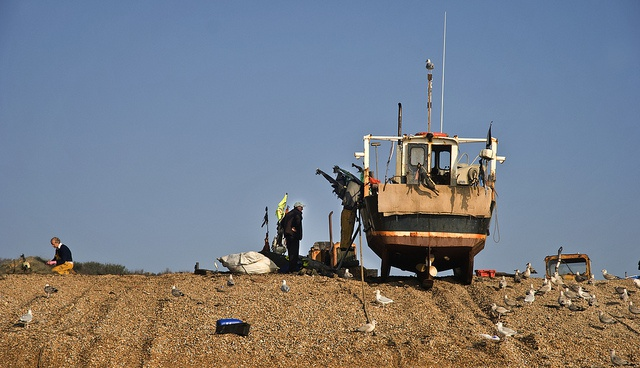Describe the objects in this image and their specific colors. I can see boat in gray, black, tan, and maroon tones, bird in gray and tan tones, people in gray, black, darkgray, and maroon tones, people in gray, black, orange, olive, and maroon tones, and bird in gray, maroon, lightgray, and black tones in this image. 